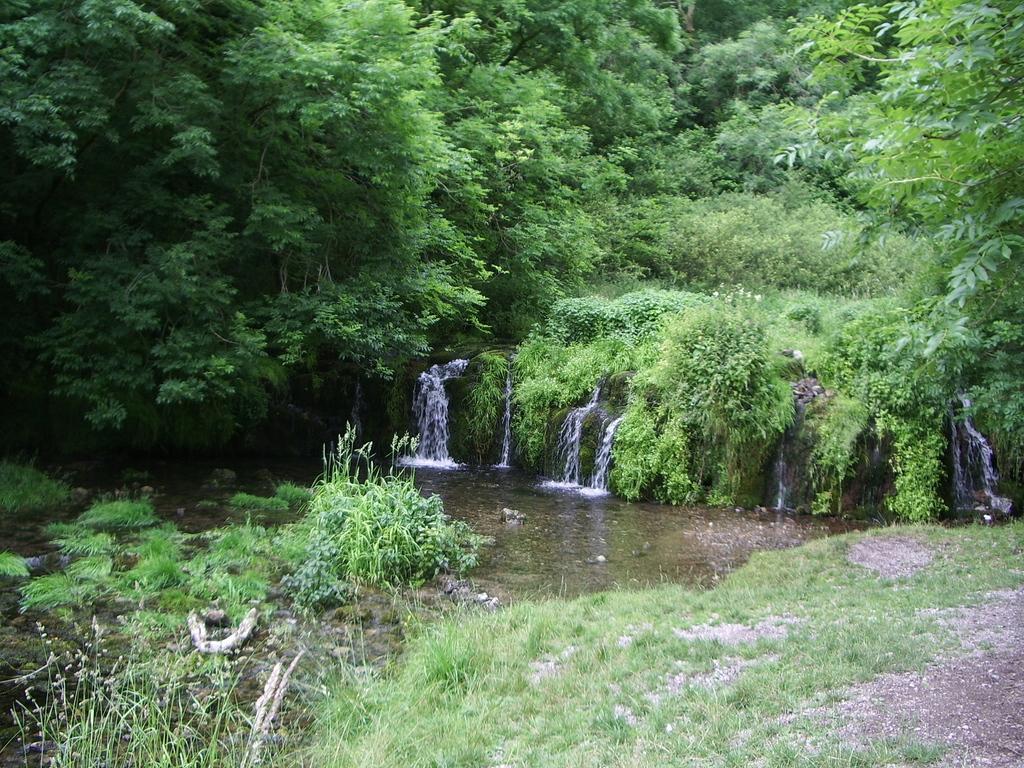How would you summarize this image in a sentence or two? In the image we can see waterfalls, grass, plant and trees. 